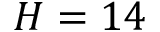Convert formula to latex. <formula><loc_0><loc_0><loc_500><loc_500>H = 1 4</formula> 